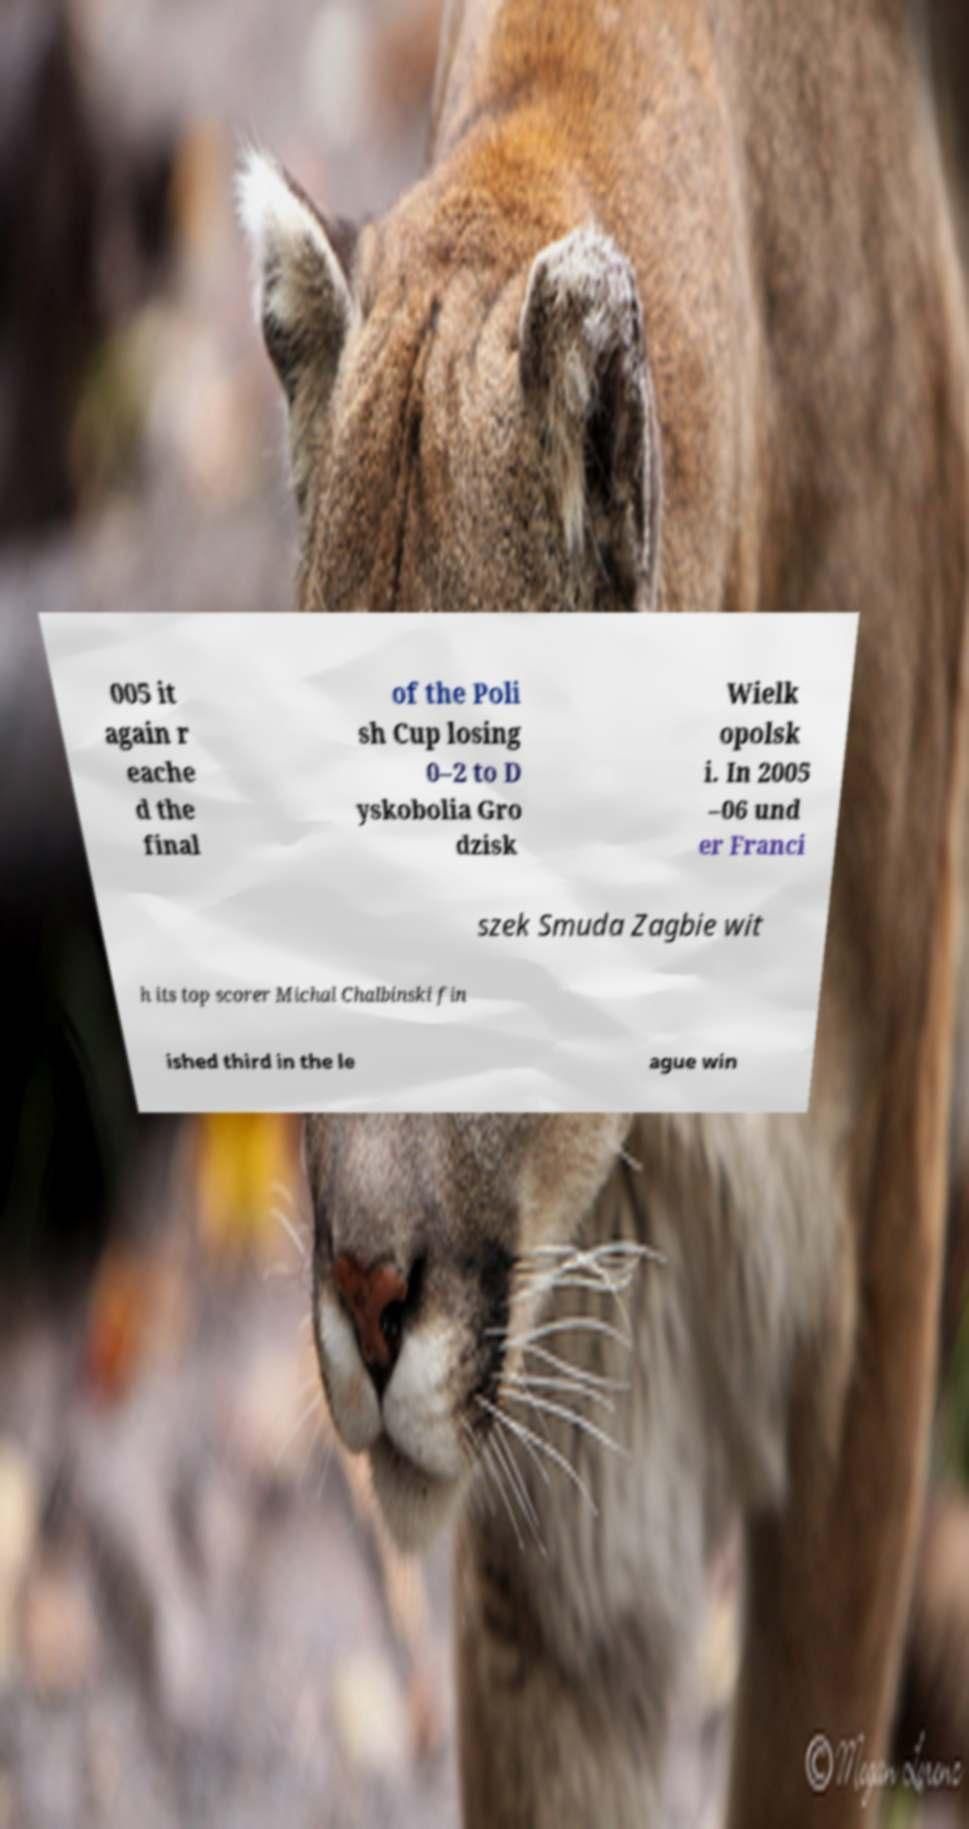Please read and relay the text visible in this image. What does it say? 005 it again r eache d the final of the Poli sh Cup losing 0–2 to D yskobolia Gro dzisk Wielk opolsk i. In 2005 –06 und er Franci szek Smuda Zagbie wit h its top scorer Michal Chalbinski fin ished third in the le ague win 